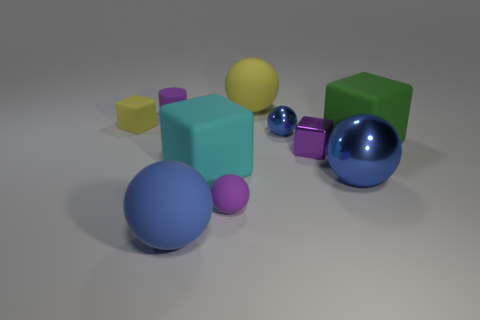Subtract all blue cylinders. How many blue spheres are left? 3 Subtract 1 blocks. How many blocks are left? 3 Subtract all purple spheres. How many spheres are left? 4 Subtract all yellow matte spheres. How many spheres are left? 4 Subtract all gray spheres. Subtract all brown cylinders. How many spheres are left? 5 Subtract all cubes. How many objects are left? 6 Subtract 0 red balls. How many objects are left? 10 Subtract all cyan matte objects. Subtract all big green rubber things. How many objects are left? 8 Add 8 large cyan matte cubes. How many large cyan matte cubes are left? 9 Add 3 tiny objects. How many tiny objects exist? 8 